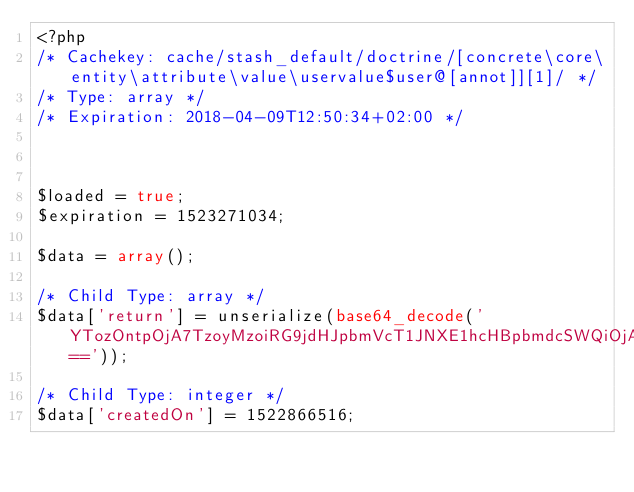<code> <loc_0><loc_0><loc_500><loc_500><_PHP_><?php 
/* Cachekey: cache/stash_default/doctrine/[concrete\core\entity\attribute\value\uservalue$user@[annot]][1]/ */
/* Type: array */
/* Expiration: 2018-04-09T12:50:34+02:00 */



$loaded = true;
$expiration = 1523271034;

$data = array();

/* Child Type: array */
$data['return'] = unserialize(base64_decode('YTozOntpOjA7TzoyMzoiRG9jdHJpbmVcT1JNXE1hcHBpbmdcSWQiOjA6e31pOjE7TzozMDoiRG9jdHJpbmVcT1JNXE1hcHBpbmdcTWFueVRvT25lIjo0OntzOjEyOiJ0YXJnZXRFbnRpdHkiO3M6MzE6IlxDb25jcmV0ZVxDb3JlXEVudGl0eVxVc2VyXFVzZXIiO3M6NzoiY2FzY2FkZSI7TjtzOjU6ImZldGNoIjtzOjQ6IkxBWlkiO3M6MTA6ImludmVyc2VkQnkiO047fWk6MjtPOjMxOiJEb2N0cmluZVxPUk1cTWFwcGluZ1xKb2luQ29sdW1uIjo3OntzOjQ6Im5hbWUiO3M6MzoidUlEIjtzOjIwOiJyZWZlcmVuY2VkQ29sdW1uTmFtZSI7czozOiJ1SUQiO3M6NjoidW5pcXVlIjtiOjA7czo4OiJudWxsYWJsZSI7YjoxO3M6ODoib25EZWxldGUiO047czoxNjoiY29sdW1uRGVmaW5pdGlvbiI7TjtzOjk6ImZpZWxkTmFtZSI7Tjt9fQ=='));

/* Child Type: integer */
$data['createdOn'] = 1522866516;
</code> 